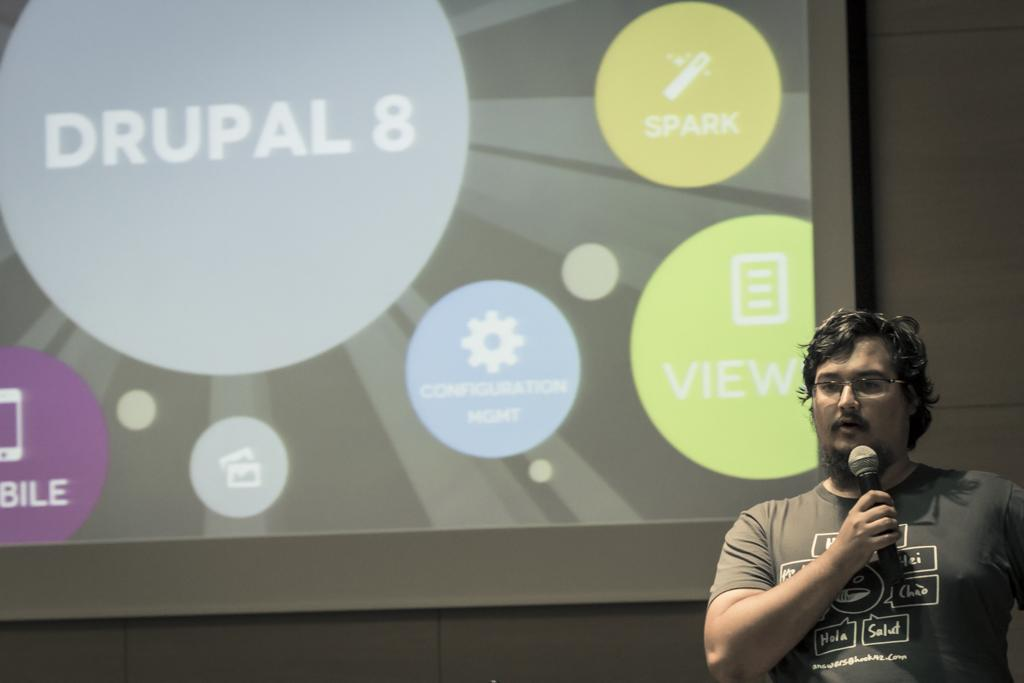Who is present on the right side of the image? There is a person on the right side of the image. What is the person holding in the image? The person is holding a microphone. What accessory is the person wearing in the image? The person is wearing glasses. What can be seen in the background of the image? There is a screen and a wall in the background of the image. What type of quilt is draped over the person's collar in the image? There is no quilt present in the image, nor is there a collar visible on the person. 